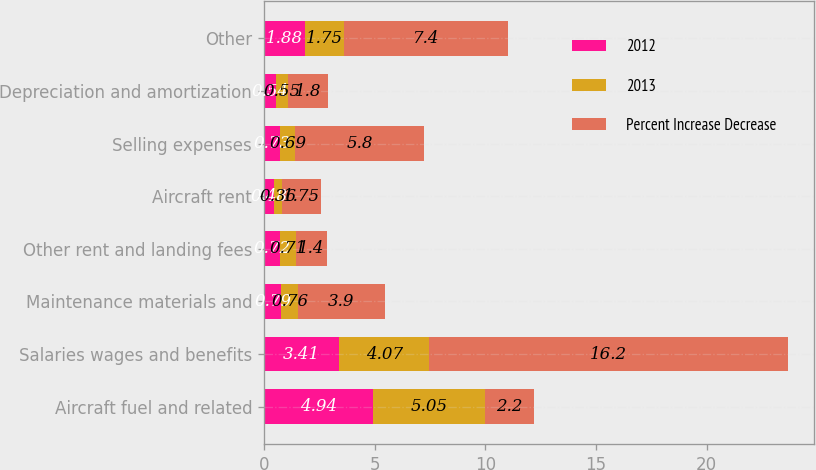Convert chart to OTSL. <chart><loc_0><loc_0><loc_500><loc_500><stacked_bar_chart><ecel><fcel>Aircraft fuel and related<fcel>Salaries wages and benefits<fcel>Maintenance materials and<fcel>Other rent and landing fees<fcel>Aircraft rent<fcel>Selling expenses<fcel>Depreciation and amortization<fcel>Other<nl><fcel>2012<fcel>4.94<fcel>3.41<fcel>0.79<fcel>0.72<fcel>0.48<fcel>0.73<fcel>0.54<fcel>1.88<nl><fcel>2013<fcel>5.05<fcel>4.07<fcel>0.76<fcel>0.71<fcel>0.36<fcel>0.69<fcel>0.55<fcel>1.75<nl><fcel>Percent Increase Decrease<fcel>2.2<fcel>16.2<fcel>3.9<fcel>1.4<fcel>1.75<fcel>5.8<fcel>1.8<fcel>7.4<nl></chart> 